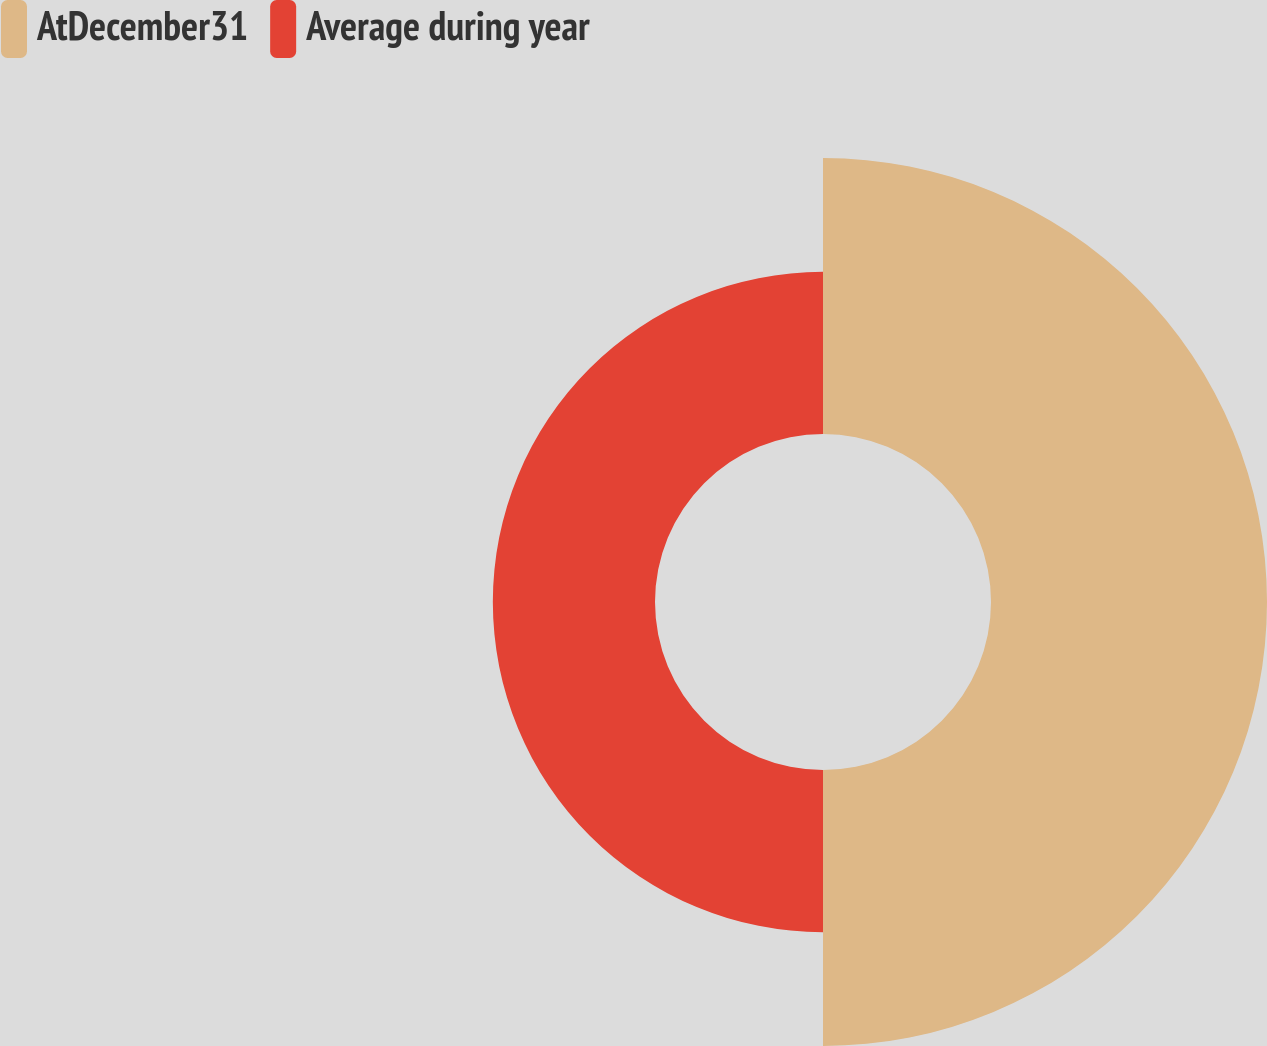<chart> <loc_0><loc_0><loc_500><loc_500><pie_chart><fcel>AtDecember31<fcel>Average during year<nl><fcel>62.99%<fcel>37.01%<nl></chart> 